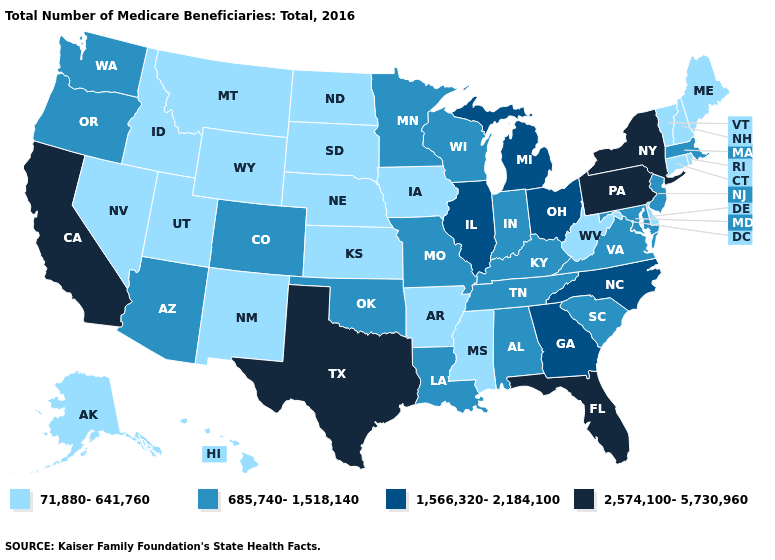What is the highest value in the South ?
Give a very brief answer. 2,574,100-5,730,960. Does Indiana have the same value as Louisiana?
Be succinct. Yes. Name the states that have a value in the range 685,740-1,518,140?
Short answer required. Alabama, Arizona, Colorado, Indiana, Kentucky, Louisiana, Maryland, Massachusetts, Minnesota, Missouri, New Jersey, Oklahoma, Oregon, South Carolina, Tennessee, Virginia, Washington, Wisconsin. What is the highest value in the South ?
Write a very short answer. 2,574,100-5,730,960. Does Nebraska have the highest value in the MidWest?
Short answer required. No. What is the value of Florida?
Be succinct. 2,574,100-5,730,960. Is the legend a continuous bar?
Keep it brief. No. Name the states that have a value in the range 2,574,100-5,730,960?
Short answer required. California, Florida, New York, Pennsylvania, Texas. Does Iowa have the same value as Nevada?
Write a very short answer. Yes. Does Texas have the highest value in the USA?
Give a very brief answer. Yes. What is the value of Georgia?
Write a very short answer. 1,566,320-2,184,100. Which states have the lowest value in the USA?
Be succinct. Alaska, Arkansas, Connecticut, Delaware, Hawaii, Idaho, Iowa, Kansas, Maine, Mississippi, Montana, Nebraska, Nevada, New Hampshire, New Mexico, North Dakota, Rhode Island, South Dakota, Utah, Vermont, West Virginia, Wyoming. Which states have the highest value in the USA?
Quick response, please. California, Florida, New York, Pennsylvania, Texas. What is the lowest value in the MidWest?
Give a very brief answer. 71,880-641,760. What is the highest value in the Northeast ?
Give a very brief answer. 2,574,100-5,730,960. 